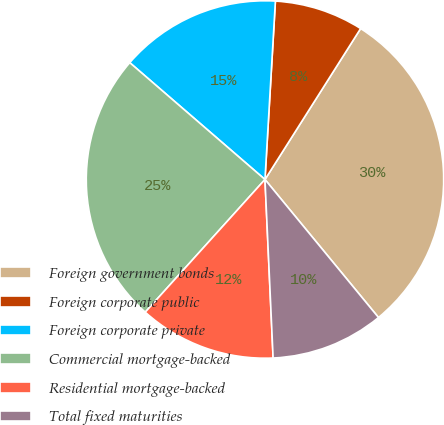Convert chart. <chart><loc_0><loc_0><loc_500><loc_500><pie_chart><fcel>Foreign government bonds<fcel>Foreign corporate public<fcel>Foreign corporate private<fcel>Commercial mortgage-backed<fcel>Residential mortgage-backed<fcel>Total fixed maturities<nl><fcel>30.06%<fcel>8.06%<fcel>14.59%<fcel>24.66%<fcel>12.41%<fcel>10.23%<nl></chart> 